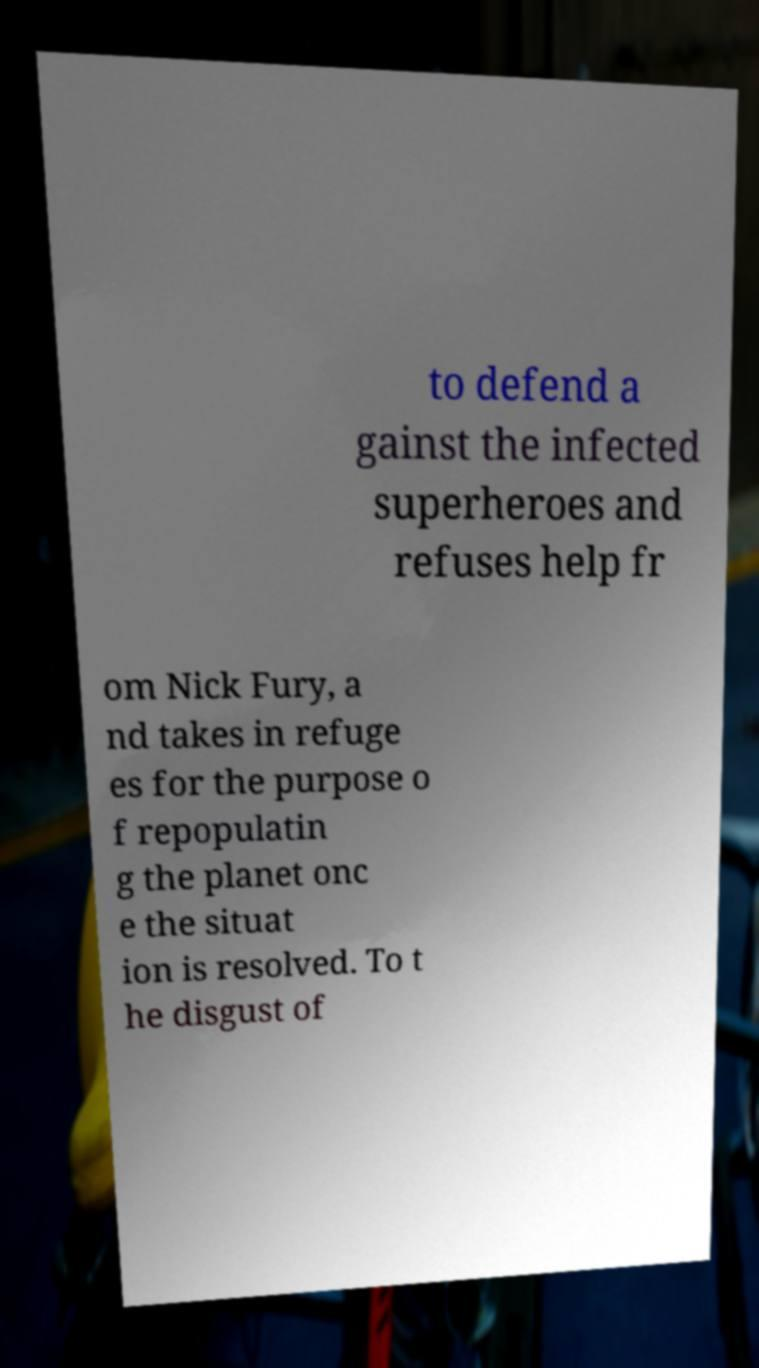Could you assist in decoding the text presented in this image and type it out clearly? to defend a gainst the infected superheroes and refuses help fr om Nick Fury, a nd takes in refuge es for the purpose o f repopulatin g the planet onc e the situat ion is resolved. To t he disgust of 